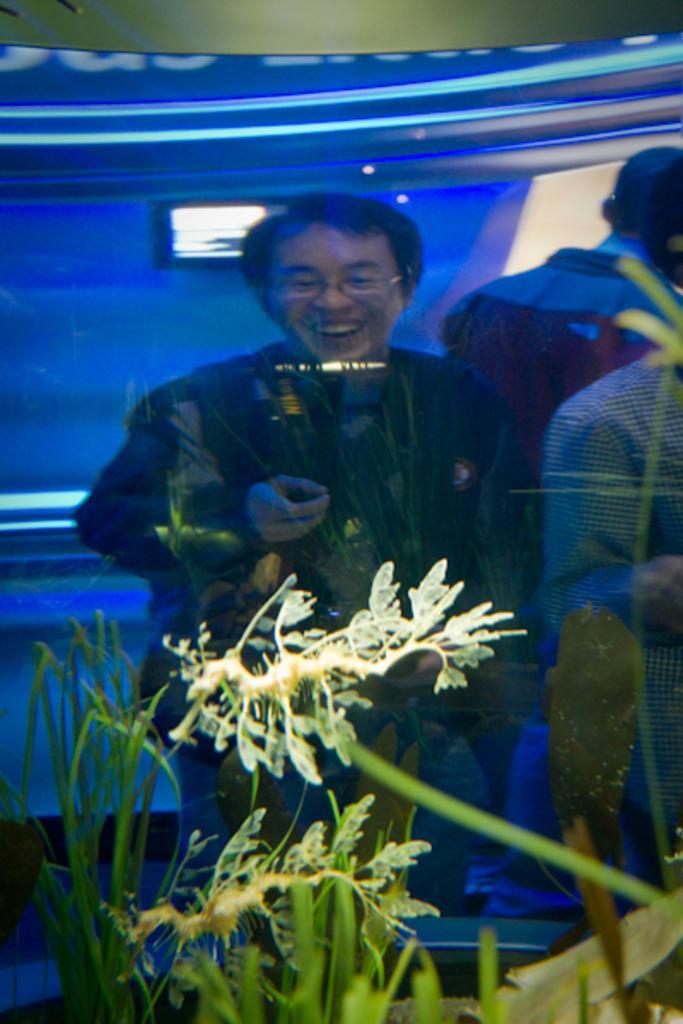Can you describe this image briefly? In this picture we can see planets, where we can see few people and some objects. 